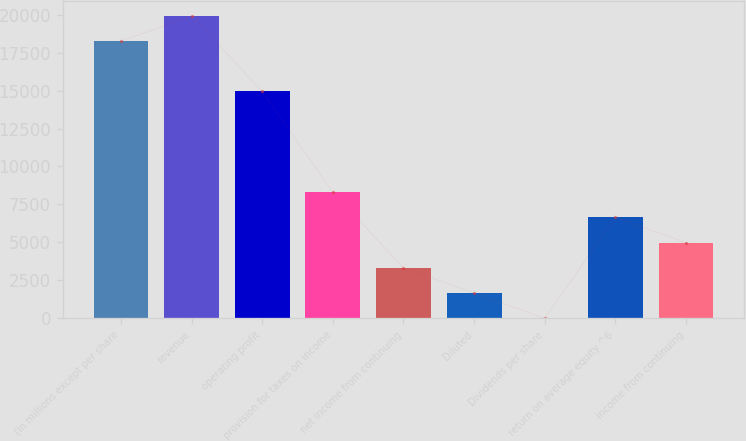Convert chart to OTSL. <chart><loc_0><loc_0><loc_500><loc_500><bar_chart><fcel>(in millions except per share<fcel>revenue<fcel>operating profit<fcel>provision for taxes on income<fcel>net income from continuing<fcel>Diluted<fcel>Dividends per share<fcel>return on average equity ^6<fcel>income from continuing<nl><fcel>18259.9<fcel>19919.8<fcel>14940.1<fcel>8300.52<fcel>3320.82<fcel>1660.92<fcel>1.02<fcel>6640.62<fcel>4980.72<nl></chart> 